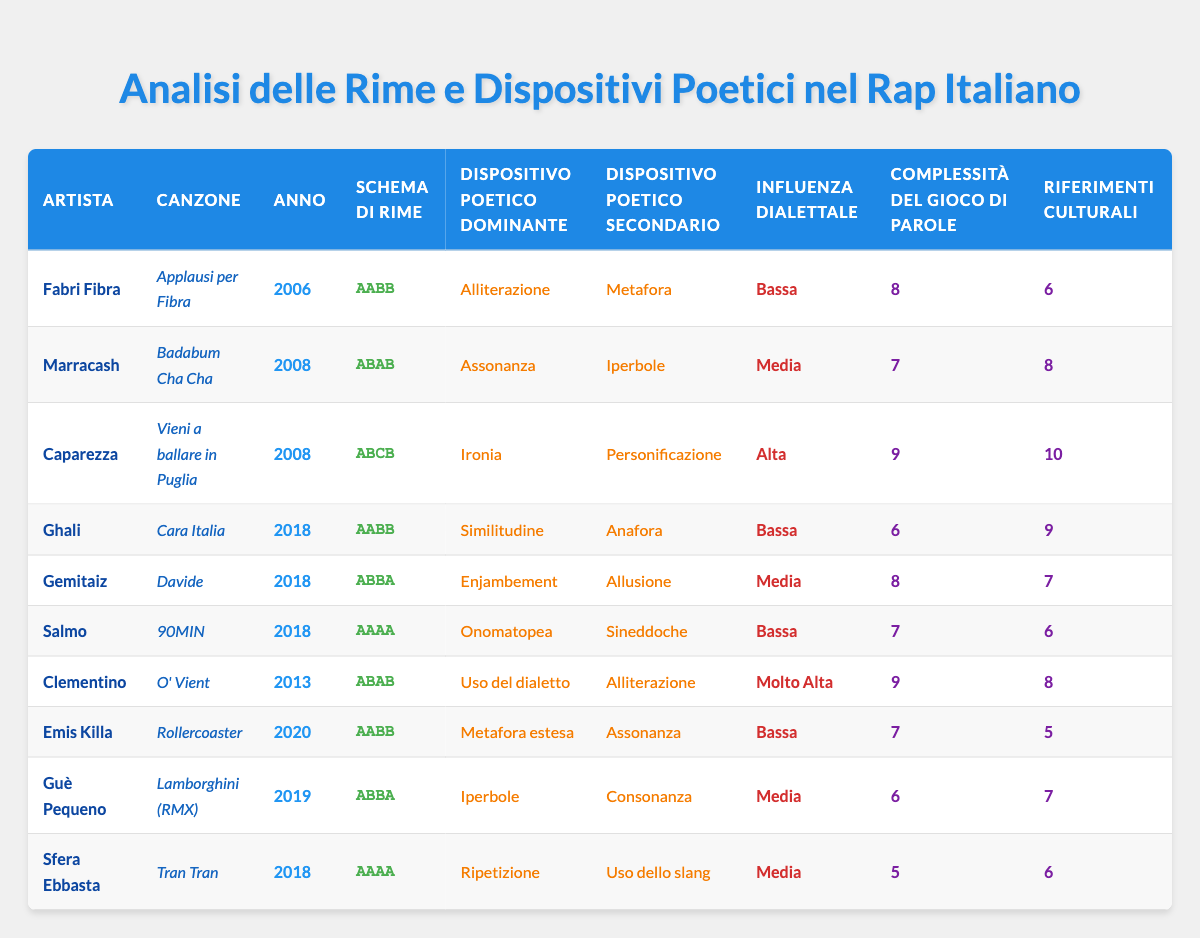What is the dominant poetic device in the song "Tran Tran" by Sfera Ebbasta? The table shows that the dominant poetic device in "Tran Tran" is "Ripetizione." We find this by looking at the row for Sfera Ebbasta and checking the column labeled "Dispositivo Poetico Dominante."
Answer: Ripetizione Which song by Caparezza has the highest cultural references? The table indicates that "Vieni a ballare in Puglia" by Caparezza has the highest number of cultural references, which is 10. This is found by locating Caparezza's song and looking at the "Riferimenti Culturali" column.
Answer: 10 Is there any song from the year 2006 that has an AABB rhyme scheme? By examining the table, we see that "Applausi per Fibra" by Fabri Fibra, released in 2006, has an AABB rhyme scheme. Hence, the answer is yes.
Answer: Yes What is the average complexity of wordplay for songs with a medium dialect influence? To find the average complexity for medium dialect influence, we first identify the songs in this category: "Badabum Cha Cha" (7), "Davide" (8), "Lamborghini (RMX)" (6), and "Tran Tran" (5). We calculate the average by summing these values: 7 + 8 + 6 + 5 = 26, and then dividing by the number of songs (4), giving us 26/4 = 6.5.
Answer: 6.5 How many songs feature irony as a dominant poetic device? From the table, we see that only one song, "Vieni a ballare in Puglia" by Caparezza, features "Ironia" as the dominant poetic device. This is checked by going down the "Dispositivo Poetico Dominante" column and counting occurrences of "Ironia."
Answer: 1 